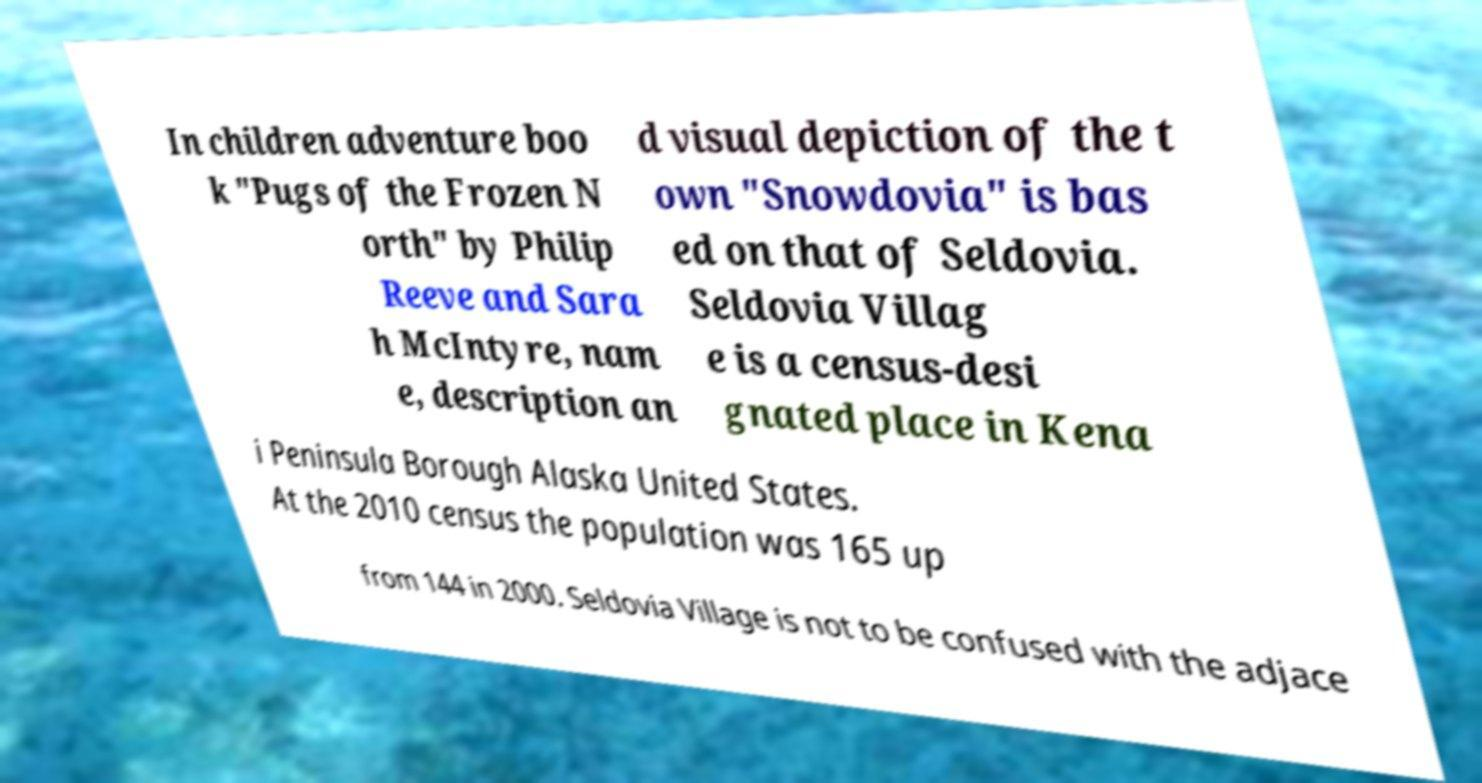What messages or text are displayed in this image? I need them in a readable, typed format. In children adventure boo k "Pugs of the Frozen N orth" by Philip Reeve and Sara h McIntyre, nam e, description an d visual depiction of the t own "Snowdovia" is bas ed on that of Seldovia. Seldovia Villag e is a census-desi gnated place in Kena i Peninsula Borough Alaska United States. At the 2010 census the population was 165 up from 144 in 2000. Seldovia Village is not to be confused with the adjace 